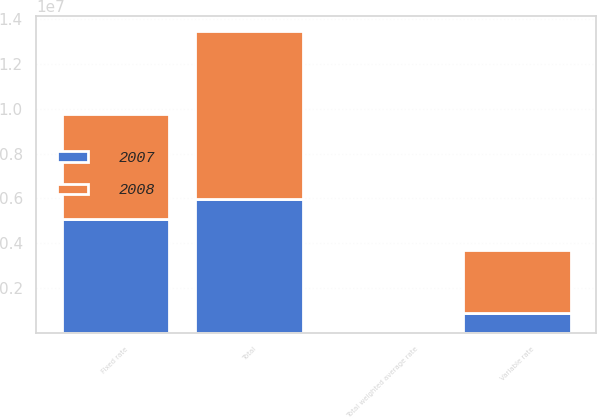<chart> <loc_0><loc_0><loc_500><loc_500><stacked_bar_chart><ecel><fcel>Fixed rate<fcel>Variable rate<fcel>Total<fcel>Total weighted average rate<nl><fcel>2007<fcel>5.05991e+06<fcel>892431<fcel>5.95234e+06<fcel>5.77<nl><fcel>2008<fcel>4.70499e+06<fcel>2.82232e+06<fcel>7.5273e+06<fcel>6.08<nl></chart> 